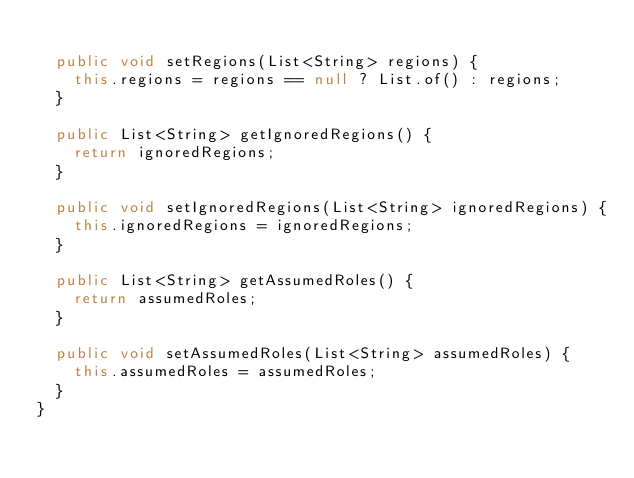<code> <loc_0><loc_0><loc_500><loc_500><_Java_>
  public void setRegions(List<String> regions) {
    this.regions = regions == null ? List.of() : regions;
  }

  public List<String> getIgnoredRegions() {
    return ignoredRegions;
  }

  public void setIgnoredRegions(List<String> ignoredRegions) {
    this.ignoredRegions = ignoredRegions;
  }

  public List<String> getAssumedRoles() {
    return assumedRoles;
  }

  public void setAssumedRoles(List<String> assumedRoles) {
    this.assumedRoles = assumedRoles;
  }
}
</code> 